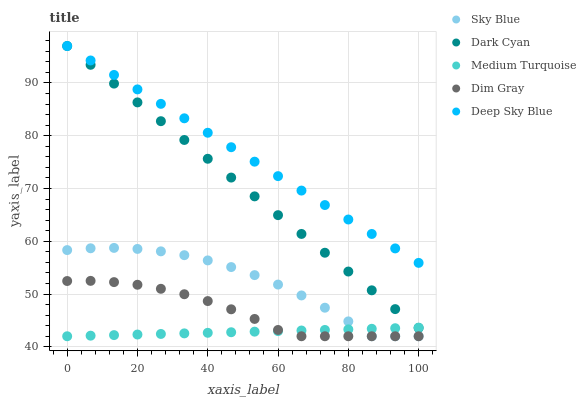Does Medium Turquoise have the minimum area under the curve?
Answer yes or no. Yes. Does Deep Sky Blue have the maximum area under the curve?
Answer yes or no. Yes. Does Sky Blue have the minimum area under the curve?
Answer yes or no. No. Does Sky Blue have the maximum area under the curve?
Answer yes or no. No. Is Medium Turquoise the smoothest?
Answer yes or no. Yes. Is Sky Blue the roughest?
Answer yes or no. Yes. Is Dim Gray the smoothest?
Answer yes or no. No. Is Dim Gray the roughest?
Answer yes or no. No. Does Sky Blue have the lowest value?
Answer yes or no. Yes. Does Deep Sky Blue have the lowest value?
Answer yes or no. No. Does Deep Sky Blue have the highest value?
Answer yes or no. Yes. Does Sky Blue have the highest value?
Answer yes or no. No. Is Sky Blue less than Dark Cyan?
Answer yes or no. Yes. Is Deep Sky Blue greater than Sky Blue?
Answer yes or no. Yes. Does Sky Blue intersect Dim Gray?
Answer yes or no. Yes. Is Sky Blue less than Dim Gray?
Answer yes or no. No. Is Sky Blue greater than Dim Gray?
Answer yes or no. No. Does Sky Blue intersect Dark Cyan?
Answer yes or no. No. 